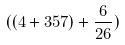Convert formula to latex. <formula><loc_0><loc_0><loc_500><loc_500>( ( 4 + 3 5 7 ) + \frac { 6 } { 2 6 } )</formula> 